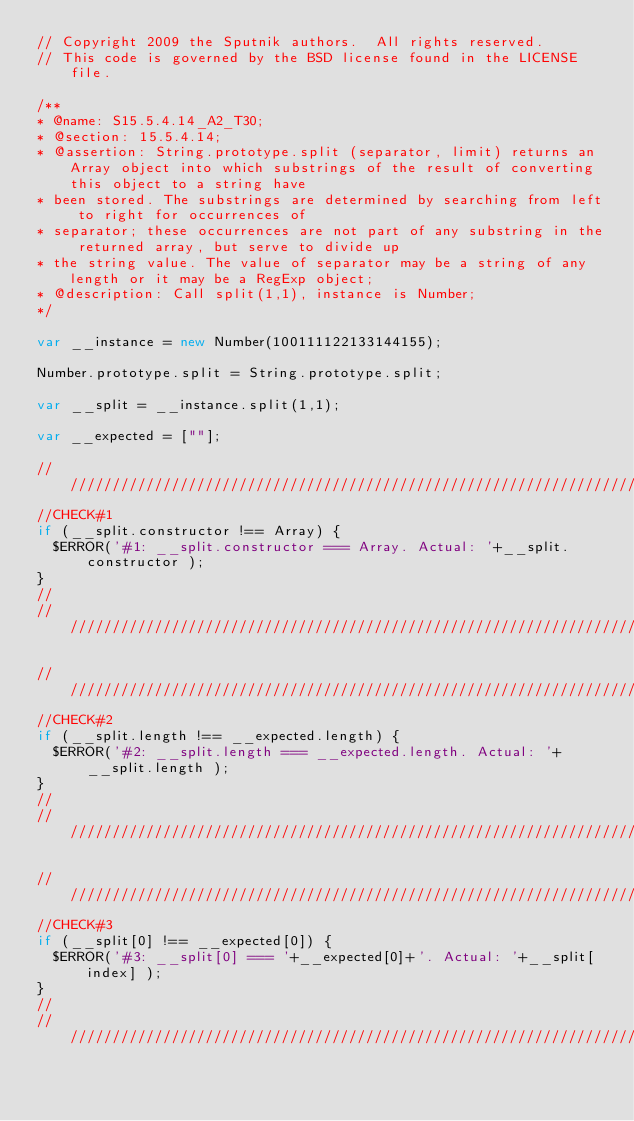Convert code to text. <code><loc_0><loc_0><loc_500><loc_500><_JavaScript_>// Copyright 2009 the Sputnik authors.  All rights reserved.
// This code is governed by the BSD license found in the LICENSE file.

/**
* @name: S15.5.4.14_A2_T30;
* @section: 15.5.4.14;
* @assertion: String.prototype.split (separator, limit) returns an Array object into which substrings of the result of converting this object to a string have
* been stored. The substrings are determined by searching from left to right for occurrences of
* separator; these occurrences are not part of any substring in the returned array, but serve to divide up
* the string value. The value of separator may be a string of any length or it may be a RegExp object;
* @description: Call split(1,1), instance is Number;
*/

var __instance = new Number(100111122133144155);

Number.prototype.split = String.prototype.split;

var __split = __instance.split(1,1);

var __expected = [""];

//////////////////////////////////////////////////////////////////////////////
//CHECK#1
if (__split.constructor !== Array) {
  $ERROR('#1: __split.constructor === Array. Actual: '+__split.constructor );
}
//
//////////////////////////////////////////////////////////////////////////////

//////////////////////////////////////////////////////////////////////////////
//CHECK#2
if (__split.length !== __expected.length) {
  $ERROR('#2: __split.length === __expected.length. Actual: '+__split.length );
}
//
//////////////////////////////////////////////////////////////////////////////

//////////////////////////////////////////////////////////////////////////////
//CHECK#3
if (__split[0] !== __expected[0]) {
  $ERROR('#3: __split[0] === '+__expected[0]+'. Actual: '+__split[index] );
}
//
//////////////////////////////////////////////////////////////////////////////

</code> 